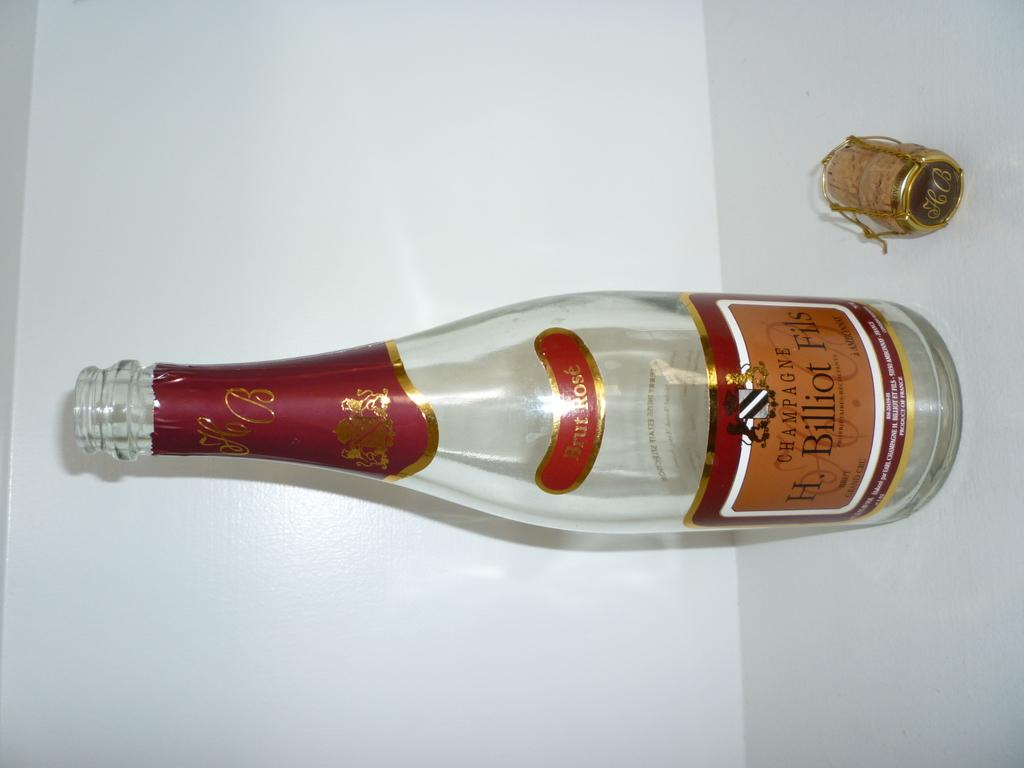<image>
Relay a brief, clear account of the picture shown. a picture of an empty bottle of H. Biliot Fils Champagne 